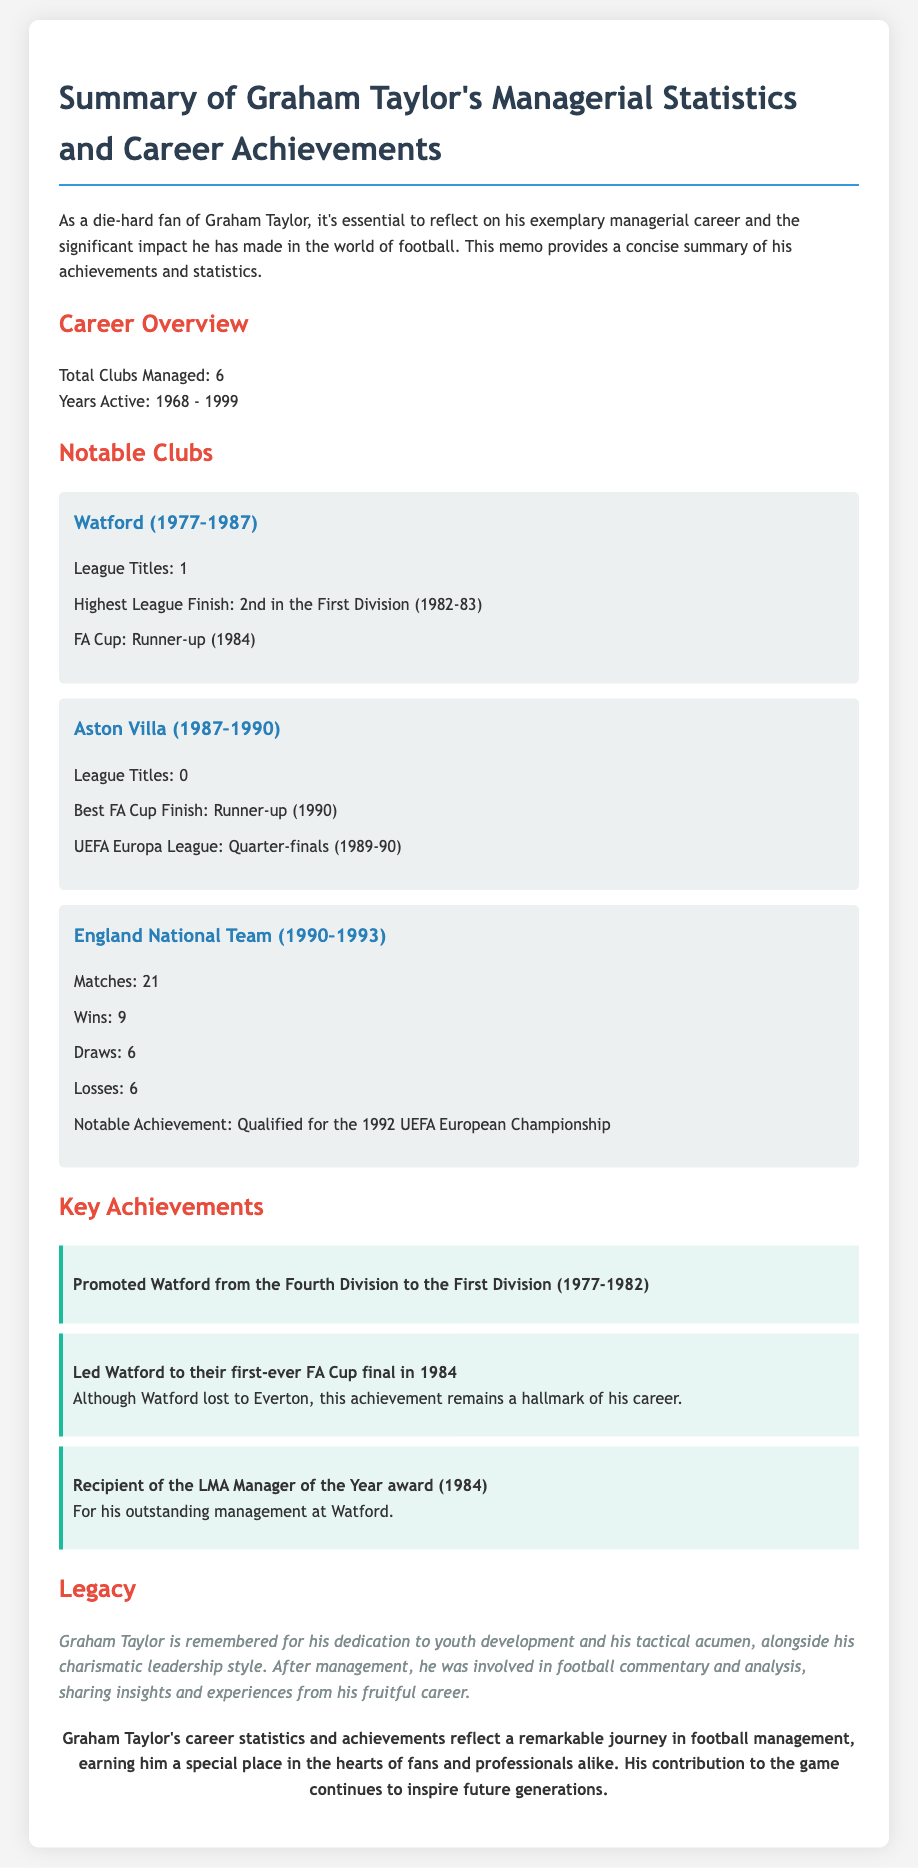What is the total number of clubs managed by Graham Taylor? The document states that Graham Taylor managed a total of 6 clubs throughout his career.
Answer: 6 In which year did Graham Taylor start his managerial career? According to the document, Graham Taylor's managerial career began in 1968.
Answer: 1968 What was Watford's highest league finish under Graham Taylor? The highest league finish for Watford under Graham Taylor was 2nd in the First Division during the 1982-83 season.
Answer: 2nd in the First Division (1982-83) Which club did Graham Taylor lead to their first-ever FA Cup final? The document notes that Watford reached their first-ever FA Cup final under Graham Taylor in 1984.
Answer: Watford How many matches did Graham Taylor manage for the England National Team? The document indicates that Graham Taylor managed 21 matches for the England National Team.
Answer: 21 Which award did Graham Taylor receive in 1984? According to the memo, Graham Taylor was the recipient of the LMA Manager of the Year award in 1984.
Answer: LMA Manager of the Year What notable achievement did Graham Taylor accomplish with Watford from 1977 to 1982? The document highlights that Graham Taylor promoted Watford from the Fourth Division to the First Division during these years.
Answer: Promoted Watford from the Fourth Division to the First Division What year did Graham Taylor manage the England National Team until? The memo states that Graham Taylor's tenure with the England National Team ended in 1993.
Answer: 1993 